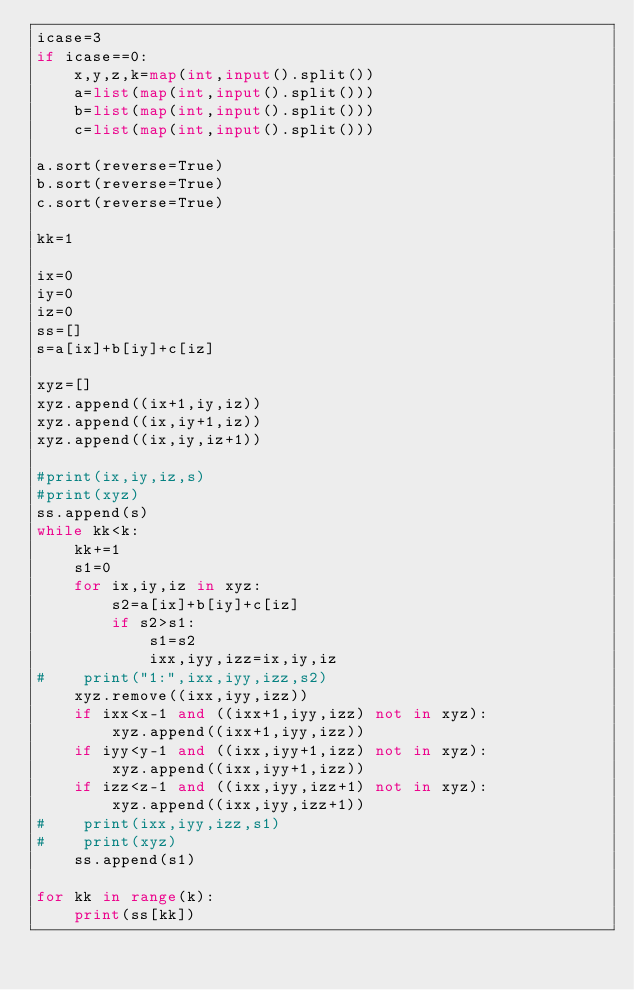<code> <loc_0><loc_0><loc_500><loc_500><_Python_>icase=3
if icase==0:
    x,y,z,k=map(int,input().split())
    a=list(map(int,input().split()))
    b=list(map(int,input().split()))
    c=list(map(int,input().split()))

a.sort(reverse=True)
b.sort(reverse=True)
c.sort(reverse=True)

kk=1

ix=0
iy=0
iz=0
ss=[]
s=a[ix]+b[iy]+c[iz]

xyz=[]
xyz.append((ix+1,iy,iz))
xyz.append((ix,iy+1,iz))
xyz.append((ix,iy,iz+1))

#print(ix,iy,iz,s)
#print(xyz)
ss.append(s)
while kk<k:
    kk+=1
    s1=0
    for ix,iy,iz in xyz:
        s2=a[ix]+b[iy]+c[iz]
        if s2>s1:
            s1=s2
            ixx,iyy,izz=ix,iy,iz
#    print("1:",ixx,iyy,izz,s2)
    xyz.remove((ixx,iyy,izz))
    if ixx<x-1 and ((ixx+1,iyy,izz) not in xyz): 
        xyz.append((ixx+1,iyy,izz))
    if iyy<y-1 and ((ixx,iyy+1,izz) not in xyz): 
        xyz.append((ixx,iyy+1,izz))
    if izz<z-1 and ((ixx,iyy,izz+1) not in xyz): 
        xyz.append((ixx,iyy,izz+1))
#    print(ixx,iyy,izz,s1)
#    print(xyz)
    ss.append(s1)

for kk in range(k):
    print(ss[kk])        
</code> 